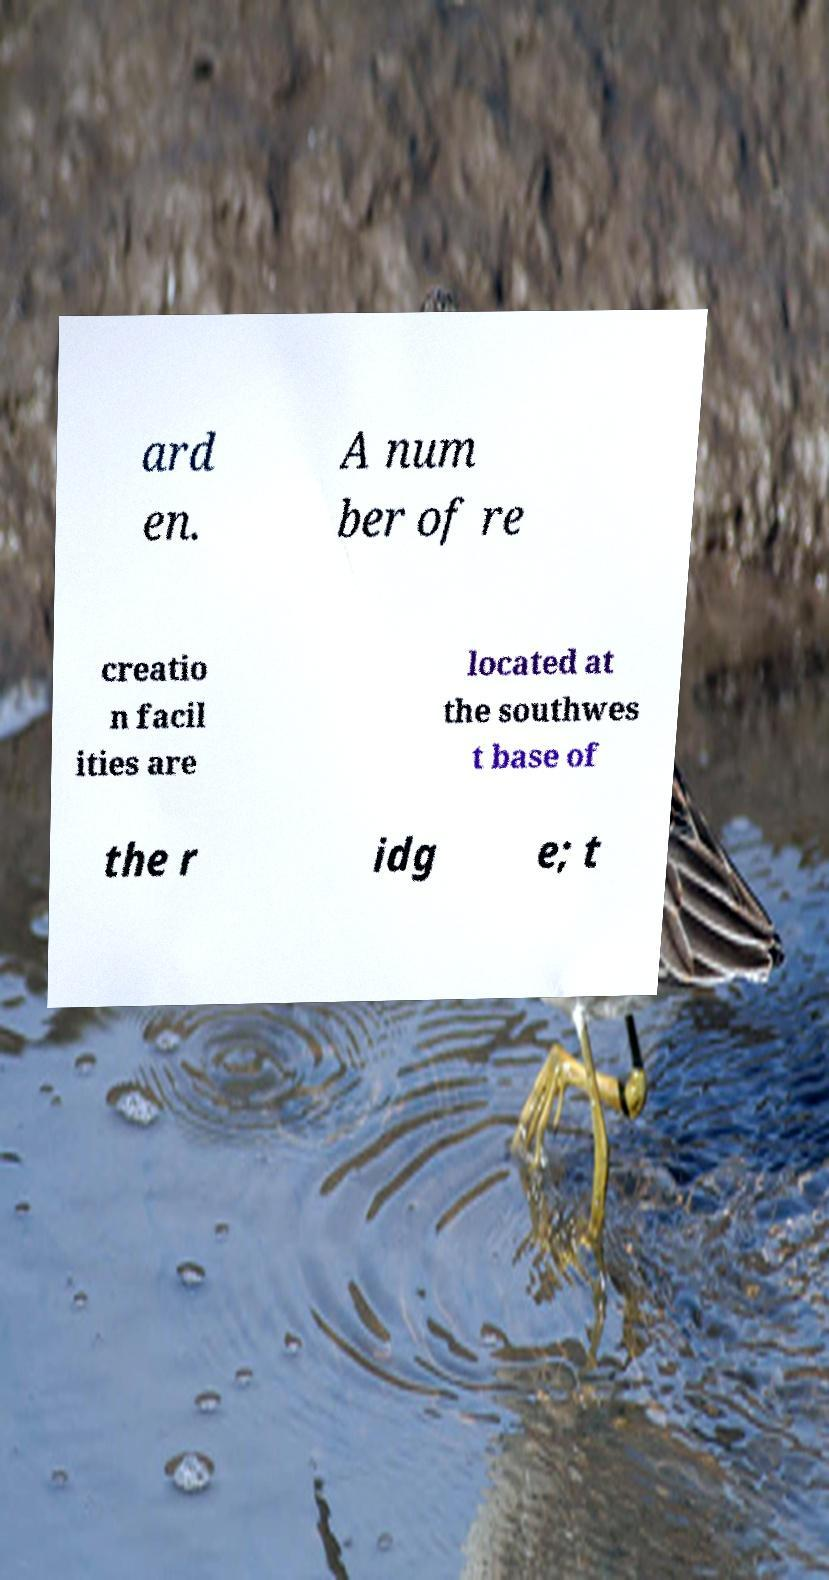Please read and relay the text visible in this image. What does it say? ard en. A num ber of re creatio n facil ities are located at the southwes t base of the r idg e; t 